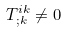<formula> <loc_0><loc_0><loc_500><loc_500>T ^ { i k } _ { ; k } \not = 0</formula> 